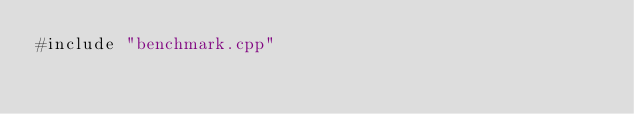<code> <loc_0><loc_0><loc_500><loc_500><_Cuda_>#include "benchmark.cpp"
</code> 